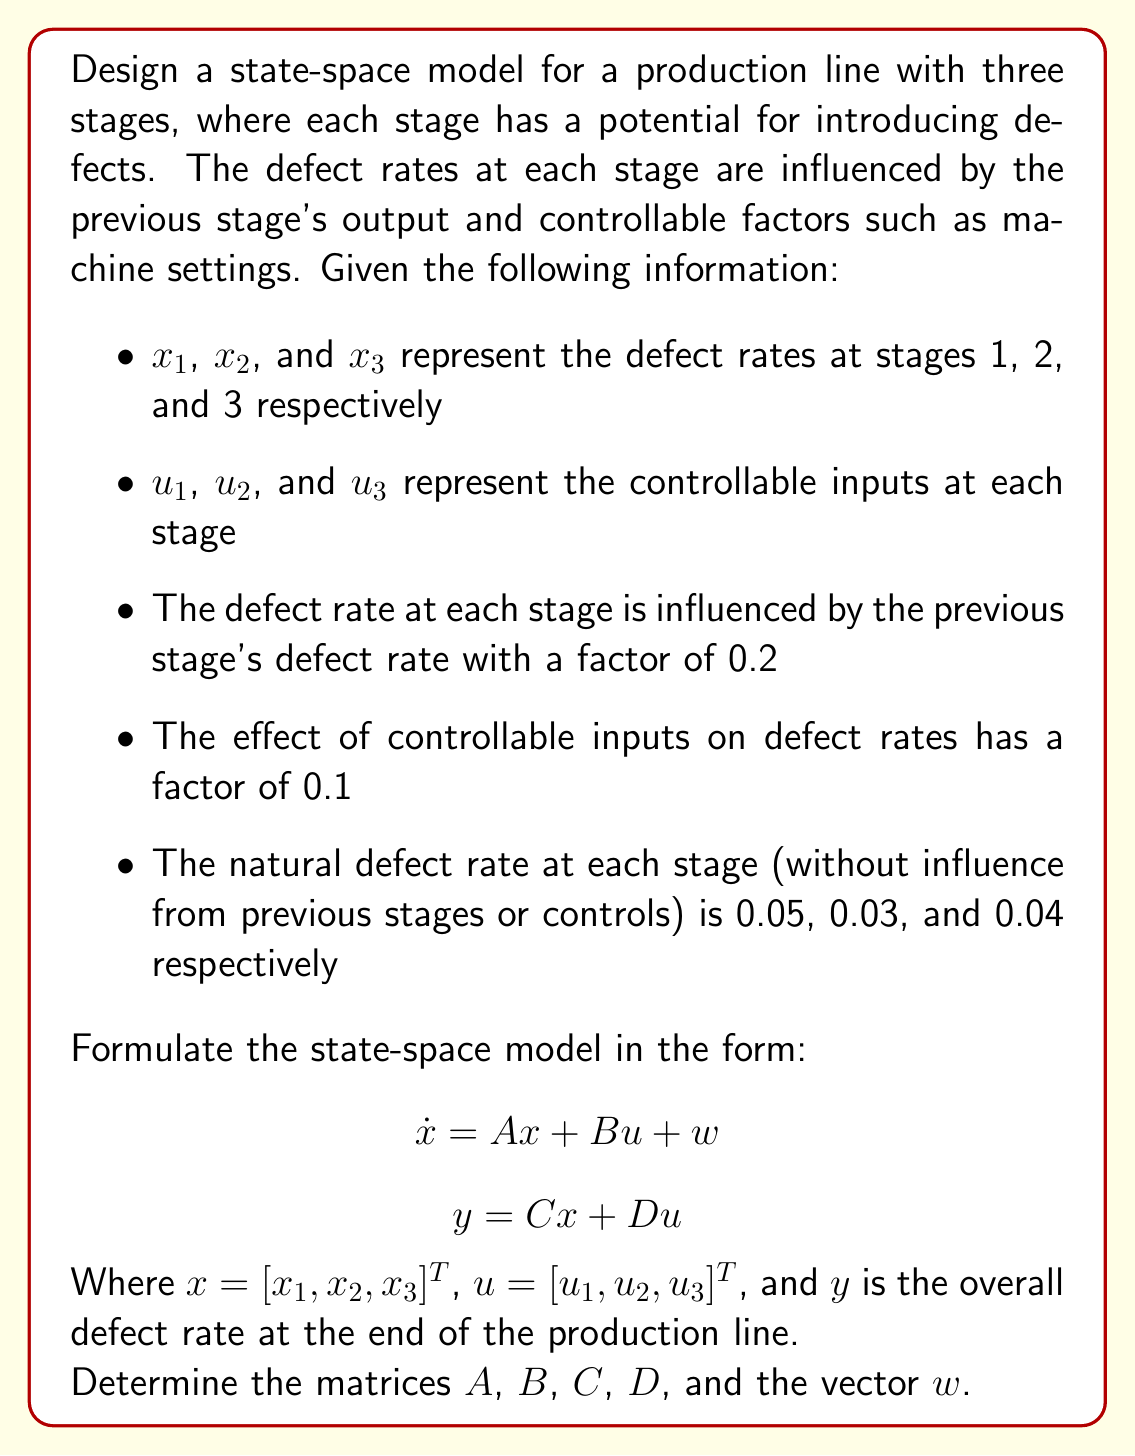Help me with this question. To design the state-space model, we need to formulate the equations for each state (defect rate at each stage) and the output equation. Let's break this down step-by-step:

1. State equations:

For $x_1$ (first stage):
$$\dot{x}_1 = 0.05 - 0.1u_1$$

For $x_2$ (second stage):
$$\dot{x}_2 = 0.03 + 0.2x_1 - 0.1u_2$$

For $x_3$ (third stage):
$$\dot{x}_3 = 0.04 + 0.2x_2 - 0.1u_3$$

2. Output equation:
The overall defect rate at the end of the production line is equal to the defect rate at the third stage:
$$y = x_3$$

3. State-space representation:

Now, we can represent these equations in the state-space form:

$$\begin{bmatrix} \dot{x}_1 \\ \dot{x}_2 \\ \dot{x}_3 \end{bmatrix} = 
\begin{bmatrix} 0 & 0 & 0 \\ 0.2 & 0 & 0 \\ 0 & 0.2 & 0 \end{bmatrix}
\begin{bmatrix} x_1 \\ x_2 \\ x_3 \end{bmatrix} + 
\begin{bmatrix} -0.1 & 0 & 0 \\ 0 & -0.1 & 0 \\ 0 & 0 & -0.1 \end{bmatrix}
\begin{bmatrix} u_1 \\ u_2 \\ u_3 \end{bmatrix} + 
\begin{bmatrix} 0.05 \\ 0.03 \\ 0.04 \end{bmatrix}$$

$$y = \begin{bmatrix} 0 & 0 & 1 \end{bmatrix} \begin{bmatrix} x_1 \\ x_2 \\ x_3 \end{bmatrix} + \begin{bmatrix} 0 & 0 & 0 \end{bmatrix} \begin{bmatrix} u_1 \\ u_2 \\ u_3 \end{bmatrix}$$

4. Identifying matrices:

From these equations, we can identify the matrices $A$, $B$, $C$, $D$, and the vector $w$:

$A = \begin{bmatrix} 0 & 0 & 0 \\ 0.2 & 0 & 0 \\ 0 & 0.2 & 0 \end{bmatrix}$

$B = \begin{bmatrix} -0.1 & 0 & 0 \\ 0 & -0.1 & 0 \\ 0 & 0 & -0.1 \end{bmatrix}$

$C = \begin{bmatrix} 0 & 0 & 1 \end{bmatrix}$

$D = \begin{bmatrix} 0 & 0 & 0 \end{bmatrix}$

$w = \begin{bmatrix} 0.05 \\ 0.03 \\ 0.04 \end{bmatrix}$
Answer: The state-space model for the production line is:

$$\dot{x} = Ax + Bu + w$$
$$y = Cx + Du$$

Where:

$A = \begin{bmatrix} 0 & 0 & 0 \\ 0.2 & 0 & 0 \\ 0 & 0.2 & 0 \end{bmatrix}$

$B = \begin{bmatrix} -0.1 & 0 & 0 \\ 0 & -0.1 & 0 \\ 0 & 0 & -0.1 \end{bmatrix}$

$C = \begin{bmatrix} 0 & 0 & 1 \end{bmatrix}$

$D = \begin{bmatrix} 0 & 0 & 0 \end{bmatrix}$

$w = \begin{bmatrix} 0.05 \\ 0.03 \\ 0.04 \end{bmatrix}$ 